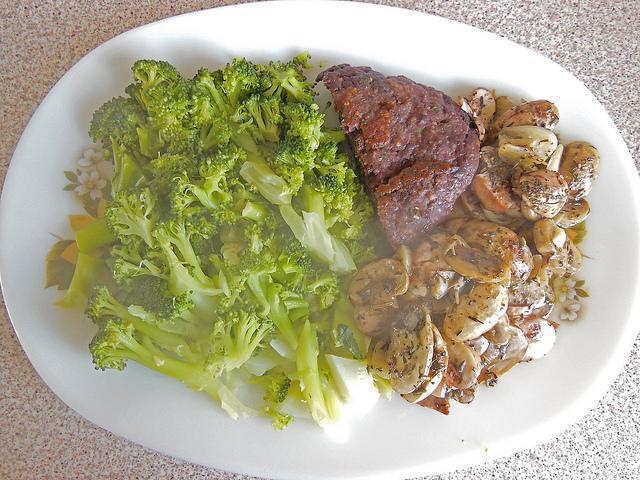Evaluate: Does the caption "The bowl contains the broccoli." match the image?
Answer yes or no. Yes. 